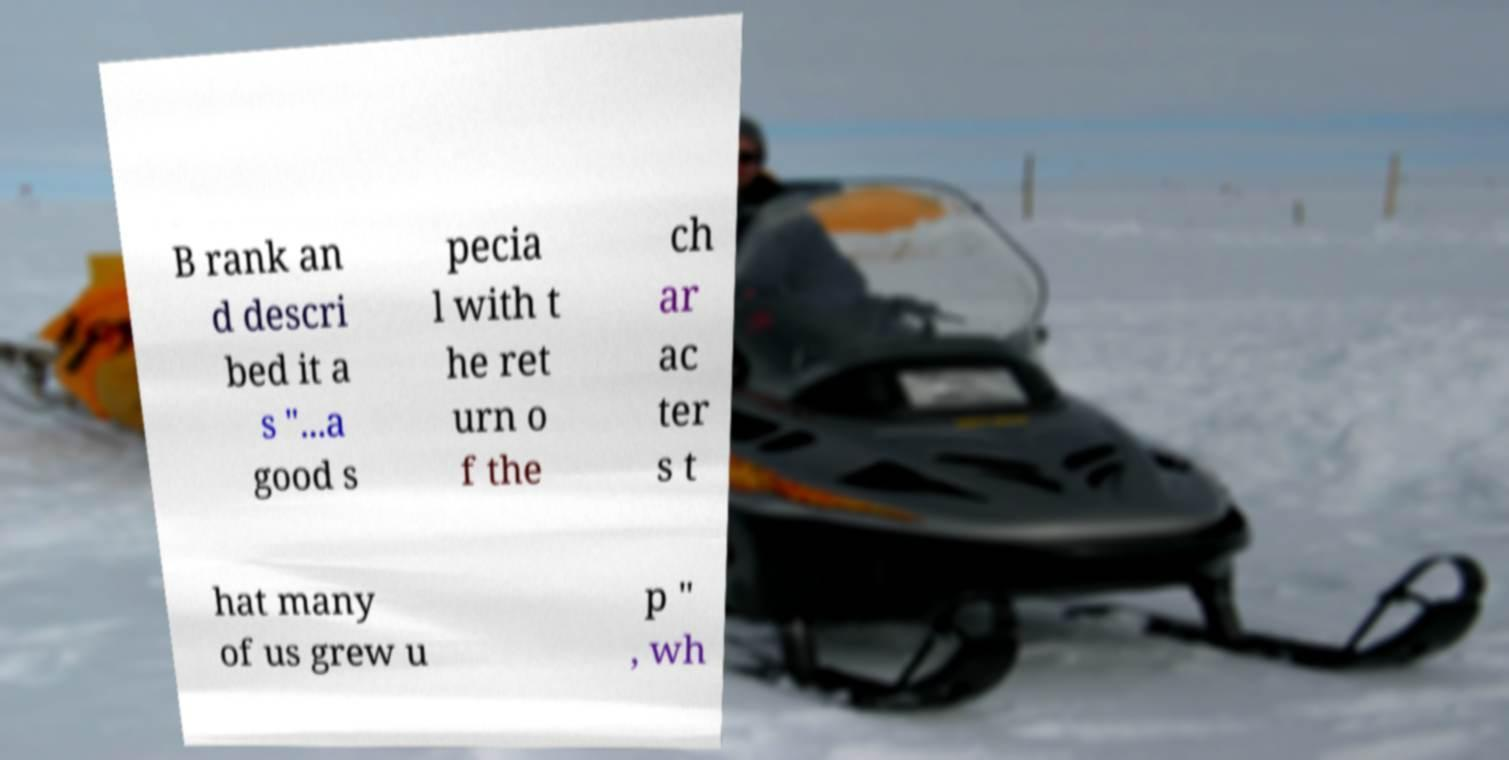Can you read and provide the text displayed in the image?This photo seems to have some interesting text. Can you extract and type it out for me? B rank an d descri bed it a s "...a good s pecia l with t he ret urn o f the ch ar ac ter s t hat many of us grew u p " , wh 